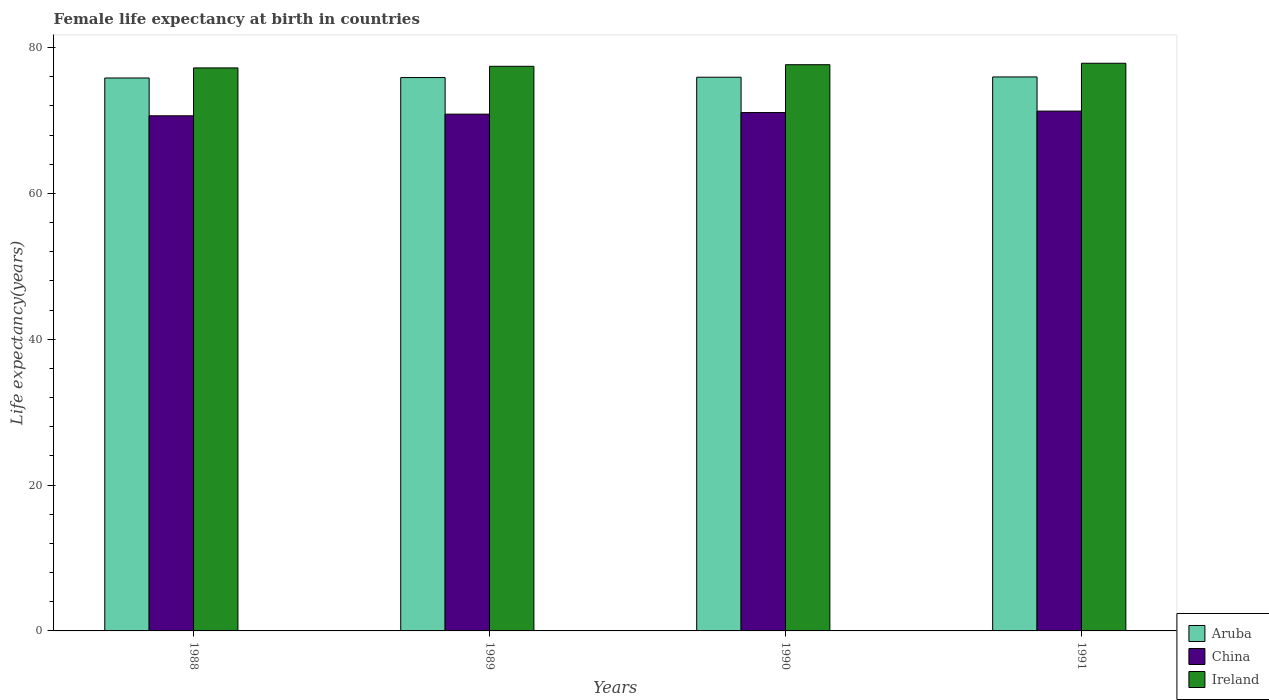How many bars are there on the 1st tick from the left?
Your response must be concise. 3. What is the female life expectancy at birth in Aruba in 1988?
Keep it short and to the point. 75.83. Across all years, what is the maximum female life expectancy at birth in Aruba?
Ensure brevity in your answer.  75.97. Across all years, what is the minimum female life expectancy at birth in Aruba?
Offer a terse response. 75.83. In which year was the female life expectancy at birth in China minimum?
Ensure brevity in your answer.  1988. What is the total female life expectancy at birth in Ireland in the graph?
Ensure brevity in your answer.  310.13. What is the difference between the female life expectancy at birth in Aruba in 1989 and that in 1990?
Your answer should be very brief. -0.05. What is the difference between the female life expectancy at birth in Ireland in 1989 and the female life expectancy at birth in Aruba in 1991?
Keep it short and to the point. 1.46. What is the average female life expectancy at birth in Aruba per year?
Provide a succinct answer. 75.9. In the year 1989, what is the difference between the female life expectancy at birth in Ireland and female life expectancy at birth in China?
Offer a terse response. 6.56. In how many years, is the female life expectancy at birth in Ireland greater than 36 years?
Provide a succinct answer. 4. What is the ratio of the female life expectancy at birth in Aruba in 1988 to that in 1990?
Your response must be concise. 1. What is the difference between the highest and the second highest female life expectancy at birth in Ireland?
Offer a very short reply. 0.2. What is the difference between the highest and the lowest female life expectancy at birth in China?
Offer a terse response. 0.64. In how many years, is the female life expectancy at birth in China greater than the average female life expectancy at birth in China taken over all years?
Your answer should be very brief. 2. Is the sum of the female life expectancy at birth in Aruba in 1989 and 1990 greater than the maximum female life expectancy at birth in Ireland across all years?
Offer a terse response. Yes. What does the 3rd bar from the left in 1991 represents?
Offer a terse response. Ireland. What does the 3rd bar from the right in 1989 represents?
Make the answer very short. Aruba. Are all the bars in the graph horizontal?
Provide a succinct answer. No. How many years are there in the graph?
Ensure brevity in your answer.  4. What is the difference between two consecutive major ticks on the Y-axis?
Ensure brevity in your answer.  20. Does the graph contain any zero values?
Make the answer very short. No. Does the graph contain grids?
Your answer should be compact. No. Where does the legend appear in the graph?
Your answer should be compact. Bottom right. How are the legend labels stacked?
Your answer should be compact. Vertical. What is the title of the graph?
Give a very brief answer. Female life expectancy at birth in countries. Does "Sint Maarten (Dutch part)" appear as one of the legend labels in the graph?
Offer a very short reply. No. What is the label or title of the Y-axis?
Ensure brevity in your answer.  Life expectancy(years). What is the Life expectancy(years) of Aruba in 1988?
Your answer should be very brief. 75.83. What is the Life expectancy(years) of China in 1988?
Give a very brief answer. 70.64. What is the Life expectancy(years) in Ireland in 1988?
Your response must be concise. 77.21. What is the Life expectancy(years) of Aruba in 1989?
Offer a terse response. 75.89. What is the Life expectancy(years) in China in 1989?
Make the answer very short. 70.87. What is the Life expectancy(years) in Ireland in 1989?
Your response must be concise. 77.43. What is the Life expectancy(years) in Aruba in 1990?
Your answer should be compact. 75.93. What is the Life expectancy(years) of China in 1990?
Provide a short and direct response. 71.09. What is the Life expectancy(years) in Ireland in 1990?
Offer a very short reply. 77.65. What is the Life expectancy(years) of Aruba in 1991?
Keep it short and to the point. 75.97. What is the Life expectancy(years) of China in 1991?
Provide a short and direct response. 71.29. What is the Life expectancy(years) of Ireland in 1991?
Ensure brevity in your answer.  77.85. Across all years, what is the maximum Life expectancy(years) of Aruba?
Make the answer very short. 75.97. Across all years, what is the maximum Life expectancy(years) in China?
Your answer should be very brief. 71.29. Across all years, what is the maximum Life expectancy(years) of Ireland?
Your answer should be compact. 77.85. Across all years, what is the minimum Life expectancy(years) in Aruba?
Offer a terse response. 75.83. Across all years, what is the minimum Life expectancy(years) of China?
Provide a short and direct response. 70.64. Across all years, what is the minimum Life expectancy(years) in Ireland?
Offer a terse response. 77.21. What is the total Life expectancy(years) in Aruba in the graph?
Your answer should be very brief. 303.61. What is the total Life expectancy(years) of China in the graph?
Make the answer very short. 283.88. What is the total Life expectancy(years) in Ireland in the graph?
Offer a terse response. 310.13. What is the difference between the Life expectancy(years) of Aruba in 1988 and that in 1989?
Provide a short and direct response. -0.06. What is the difference between the Life expectancy(years) in China in 1988 and that in 1989?
Provide a succinct answer. -0.23. What is the difference between the Life expectancy(years) of Ireland in 1988 and that in 1989?
Your answer should be compact. -0.22. What is the difference between the Life expectancy(years) of Aruba in 1988 and that in 1990?
Offer a very short reply. -0.1. What is the difference between the Life expectancy(years) of China in 1988 and that in 1990?
Your answer should be compact. -0.44. What is the difference between the Life expectancy(years) in Ireland in 1988 and that in 1990?
Give a very brief answer. -0.44. What is the difference between the Life expectancy(years) of Aruba in 1988 and that in 1991?
Make the answer very short. -0.14. What is the difference between the Life expectancy(years) of China in 1988 and that in 1991?
Make the answer very short. -0.64. What is the difference between the Life expectancy(years) in Ireland in 1988 and that in 1991?
Offer a very short reply. -0.64. What is the difference between the Life expectancy(years) of Aruba in 1989 and that in 1990?
Provide a short and direct response. -0.05. What is the difference between the Life expectancy(years) in China in 1989 and that in 1990?
Your response must be concise. -0.22. What is the difference between the Life expectancy(years) of Ireland in 1989 and that in 1990?
Your answer should be compact. -0.22. What is the difference between the Life expectancy(years) in Aruba in 1989 and that in 1991?
Offer a very short reply. -0.08. What is the difference between the Life expectancy(years) in China in 1989 and that in 1991?
Give a very brief answer. -0.42. What is the difference between the Life expectancy(years) in Ireland in 1989 and that in 1991?
Provide a succinct answer. -0.42. What is the difference between the Life expectancy(years) in Aruba in 1990 and that in 1991?
Your answer should be very brief. -0.04. What is the difference between the Life expectancy(years) of Ireland in 1990 and that in 1991?
Provide a short and direct response. -0.2. What is the difference between the Life expectancy(years) in Aruba in 1988 and the Life expectancy(years) in China in 1989?
Make the answer very short. 4.96. What is the difference between the Life expectancy(years) of Aruba in 1988 and the Life expectancy(years) of Ireland in 1989?
Make the answer very short. -1.6. What is the difference between the Life expectancy(years) of China in 1988 and the Life expectancy(years) of Ireland in 1989?
Give a very brief answer. -6.79. What is the difference between the Life expectancy(years) in Aruba in 1988 and the Life expectancy(years) in China in 1990?
Ensure brevity in your answer.  4.74. What is the difference between the Life expectancy(years) of Aruba in 1988 and the Life expectancy(years) of Ireland in 1990?
Your response must be concise. -1.82. What is the difference between the Life expectancy(years) in China in 1988 and the Life expectancy(years) in Ireland in 1990?
Offer a terse response. -7. What is the difference between the Life expectancy(years) of Aruba in 1988 and the Life expectancy(years) of China in 1991?
Ensure brevity in your answer.  4.54. What is the difference between the Life expectancy(years) of Aruba in 1988 and the Life expectancy(years) of Ireland in 1991?
Your response must be concise. -2.02. What is the difference between the Life expectancy(years) of China in 1988 and the Life expectancy(years) of Ireland in 1991?
Your answer should be compact. -7.2. What is the difference between the Life expectancy(years) of Aruba in 1989 and the Life expectancy(years) of Ireland in 1990?
Offer a very short reply. -1.76. What is the difference between the Life expectancy(years) of China in 1989 and the Life expectancy(years) of Ireland in 1990?
Ensure brevity in your answer.  -6.78. What is the difference between the Life expectancy(years) of Aruba in 1989 and the Life expectancy(years) of Ireland in 1991?
Ensure brevity in your answer.  -1.96. What is the difference between the Life expectancy(years) in China in 1989 and the Life expectancy(years) in Ireland in 1991?
Offer a terse response. -6.98. What is the difference between the Life expectancy(years) of Aruba in 1990 and the Life expectancy(years) of China in 1991?
Your response must be concise. 4.65. What is the difference between the Life expectancy(years) of Aruba in 1990 and the Life expectancy(years) of Ireland in 1991?
Offer a very short reply. -1.92. What is the difference between the Life expectancy(years) of China in 1990 and the Life expectancy(years) of Ireland in 1991?
Your response must be concise. -6.76. What is the average Life expectancy(years) in Aruba per year?
Your answer should be compact. 75.9. What is the average Life expectancy(years) in China per year?
Offer a terse response. 70.97. What is the average Life expectancy(years) in Ireland per year?
Keep it short and to the point. 77.53. In the year 1988, what is the difference between the Life expectancy(years) of Aruba and Life expectancy(years) of China?
Provide a succinct answer. 5.18. In the year 1988, what is the difference between the Life expectancy(years) in Aruba and Life expectancy(years) in Ireland?
Provide a succinct answer. -1.38. In the year 1988, what is the difference between the Life expectancy(years) in China and Life expectancy(years) in Ireland?
Keep it short and to the point. -6.57. In the year 1989, what is the difference between the Life expectancy(years) of Aruba and Life expectancy(years) of China?
Your answer should be compact. 5.02. In the year 1989, what is the difference between the Life expectancy(years) in Aruba and Life expectancy(years) in Ireland?
Give a very brief answer. -1.54. In the year 1989, what is the difference between the Life expectancy(years) of China and Life expectancy(years) of Ireland?
Your answer should be very brief. -6.56. In the year 1990, what is the difference between the Life expectancy(years) of Aruba and Life expectancy(years) of China?
Make the answer very short. 4.85. In the year 1990, what is the difference between the Life expectancy(years) in Aruba and Life expectancy(years) in Ireland?
Offer a terse response. -1.72. In the year 1990, what is the difference between the Life expectancy(years) of China and Life expectancy(years) of Ireland?
Provide a short and direct response. -6.56. In the year 1991, what is the difference between the Life expectancy(years) of Aruba and Life expectancy(years) of China?
Provide a short and direct response. 4.68. In the year 1991, what is the difference between the Life expectancy(years) of Aruba and Life expectancy(years) of Ireland?
Provide a short and direct response. -1.88. In the year 1991, what is the difference between the Life expectancy(years) of China and Life expectancy(years) of Ireland?
Your answer should be very brief. -6.56. What is the ratio of the Life expectancy(years) in Aruba in 1988 to that in 1989?
Your answer should be very brief. 1. What is the ratio of the Life expectancy(years) of China in 1988 to that in 1989?
Provide a succinct answer. 1. What is the ratio of the Life expectancy(years) in Aruba in 1988 to that in 1990?
Offer a very short reply. 1. What is the ratio of the Life expectancy(years) of China in 1988 to that in 1990?
Keep it short and to the point. 0.99. What is the ratio of the Life expectancy(years) of Ireland in 1988 to that in 1990?
Your answer should be very brief. 0.99. What is the ratio of the Life expectancy(years) of Aruba in 1988 to that in 1991?
Offer a very short reply. 1. What is the ratio of the Life expectancy(years) in Aruba in 1989 to that in 1990?
Provide a succinct answer. 1. What is the ratio of the Life expectancy(years) in China in 1989 to that in 1990?
Your answer should be very brief. 1. What is the ratio of the Life expectancy(years) in China in 1989 to that in 1991?
Offer a terse response. 0.99. What is the ratio of the Life expectancy(years) in Ireland in 1989 to that in 1991?
Make the answer very short. 0.99. What is the ratio of the Life expectancy(years) in China in 1990 to that in 1991?
Your answer should be very brief. 1. What is the difference between the highest and the second highest Life expectancy(years) in Aruba?
Provide a short and direct response. 0.04. What is the difference between the highest and the lowest Life expectancy(years) in Aruba?
Provide a short and direct response. 0.14. What is the difference between the highest and the lowest Life expectancy(years) of China?
Your answer should be very brief. 0.64. What is the difference between the highest and the lowest Life expectancy(years) of Ireland?
Provide a succinct answer. 0.64. 